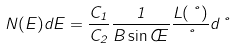<formula> <loc_0><loc_0><loc_500><loc_500>N ( E ) d E = \frac { C _ { 1 } } { C _ { 2 } } \frac { 1 } { B \sin \phi } \frac { L ( \nu ) } { \nu } d \nu</formula> 